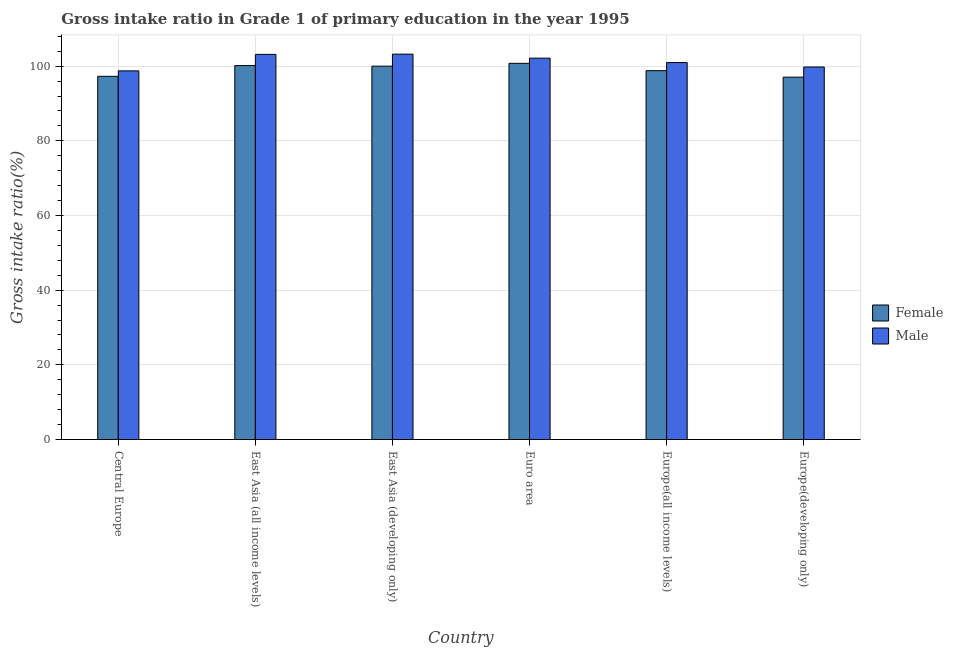How many different coloured bars are there?
Keep it short and to the point. 2. How many bars are there on the 5th tick from the left?
Make the answer very short. 2. What is the label of the 1st group of bars from the left?
Your answer should be compact. Central Europe. What is the gross intake ratio(female) in Euro area?
Ensure brevity in your answer.  100.76. Across all countries, what is the maximum gross intake ratio(male)?
Ensure brevity in your answer.  103.22. Across all countries, what is the minimum gross intake ratio(female)?
Ensure brevity in your answer.  97.06. In which country was the gross intake ratio(female) maximum?
Your answer should be very brief. Euro area. In which country was the gross intake ratio(male) minimum?
Offer a very short reply. Central Europe. What is the total gross intake ratio(female) in the graph?
Keep it short and to the point. 594.04. What is the difference between the gross intake ratio(female) in East Asia (all income levels) and that in Europe(all income levels)?
Provide a succinct answer. 1.36. What is the difference between the gross intake ratio(female) in Euro area and the gross intake ratio(male) in East Asia (all income levels)?
Your answer should be compact. -2.39. What is the average gross intake ratio(male) per country?
Offer a very short reply. 101.33. What is the difference between the gross intake ratio(male) and gross intake ratio(female) in Central Europe?
Your answer should be very brief. 1.46. In how many countries, is the gross intake ratio(male) greater than 92 %?
Your answer should be very brief. 6. What is the ratio of the gross intake ratio(male) in East Asia (all income levels) to that in Euro area?
Provide a succinct answer. 1.01. Is the difference between the gross intake ratio(male) in East Asia (developing only) and Europe(developing only) greater than the difference between the gross intake ratio(female) in East Asia (developing only) and Europe(developing only)?
Make the answer very short. Yes. What is the difference between the highest and the second highest gross intake ratio(male)?
Ensure brevity in your answer.  0.07. What is the difference between the highest and the lowest gross intake ratio(male)?
Make the answer very short. 4.48. What does the 2nd bar from the left in Europe(all income levels) represents?
Provide a short and direct response. Male. What does the 2nd bar from the right in Euro area represents?
Keep it short and to the point. Female. How many bars are there?
Provide a succinct answer. 12. Are all the bars in the graph horizontal?
Keep it short and to the point. No. Where does the legend appear in the graph?
Give a very brief answer. Center right. How many legend labels are there?
Provide a succinct answer. 2. How are the legend labels stacked?
Provide a succinct answer. Vertical. What is the title of the graph?
Ensure brevity in your answer.  Gross intake ratio in Grade 1 of primary education in the year 1995. Does "Manufacturing industries and construction" appear as one of the legend labels in the graph?
Give a very brief answer. No. What is the label or title of the X-axis?
Keep it short and to the point. Country. What is the label or title of the Y-axis?
Ensure brevity in your answer.  Gross intake ratio(%). What is the Gross intake ratio(%) of Female in Central Europe?
Make the answer very short. 97.28. What is the Gross intake ratio(%) in Male in Central Europe?
Your answer should be very brief. 98.74. What is the Gross intake ratio(%) of Female in East Asia (all income levels)?
Offer a terse response. 100.15. What is the Gross intake ratio(%) in Male in East Asia (all income levels)?
Give a very brief answer. 103.15. What is the Gross intake ratio(%) of Female in East Asia (developing only)?
Provide a short and direct response. 100. What is the Gross intake ratio(%) of Male in East Asia (developing only)?
Give a very brief answer. 103.22. What is the Gross intake ratio(%) in Female in Euro area?
Provide a succinct answer. 100.76. What is the Gross intake ratio(%) of Male in Euro area?
Make the answer very short. 102.14. What is the Gross intake ratio(%) in Female in Europe(all income levels)?
Give a very brief answer. 98.79. What is the Gross intake ratio(%) in Male in Europe(all income levels)?
Ensure brevity in your answer.  100.96. What is the Gross intake ratio(%) in Female in Europe(developing only)?
Offer a terse response. 97.06. What is the Gross intake ratio(%) of Male in Europe(developing only)?
Offer a very short reply. 99.78. Across all countries, what is the maximum Gross intake ratio(%) of Female?
Provide a short and direct response. 100.76. Across all countries, what is the maximum Gross intake ratio(%) in Male?
Offer a terse response. 103.22. Across all countries, what is the minimum Gross intake ratio(%) in Female?
Your answer should be very brief. 97.06. Across all countries, what is the minimum Gross intake ratio(%) of Male?
Offer a very short reply. 98.74. What is the total Gross intake ratio(%) of Female in the graph?
Offer a terse response. 594.04. What is the total Gross intake ratio(%) in Male in the graph?
Offer a very short reply. 607.99. What is the difference between the Gross intake ratio(%) in Female in Central Europe and that in East Asia (all income levels)?
Your answer should be compact. -2.87. What is the difference between the Gross intake ratio(%) of Male in Central Europe and that in East Asia (all income levels)?
Your answer should be compact. -4.41. What is the difference between the Gross intake ratio(%) in Female in Central Europe and that in East Asia (developing only)?
Ensure brevity in your answer.  -2.72. What is the difference between the Gross intake ratio(%) of Male in Central Europe and that in East Asia (developing only)?
Make the answer very short. -4.48. What is the difference between the Gross intake ratio(%) in Female in Central Europe and that in Euro area?
Your answer should be compact. -3.48. What is the difference between the Gross intake ratio(%) in Male in Central Europe and that in Euro area?
Your answer should be very brief. -3.4. What is the difference between the Gross intake ratio(%) in Female in Central Europe and that in Europe(all income levels)?
Keep it short and to the point. -1.51. What is the difference between the Gross intake ratio(%) in Male in Central Europe and that in Europe(all income levels)?
Keep it short and to the point. -2.22. What is the difference between the Gross intake ratio(%) of Female in Central Europe and that in Europe(developing only)?
Give a very brief answer. 0.22. What is the difference between the Gross intake ratio(%) in Male in Central Europe and that in Europe(developing only)?
Provide a short and direct response. -1.04. What is the difference between the Gross intake ratio(%) of Female in East Asia (all income levels) and that in East Asia (developing only)?
Your response must be concise. 0.15. What is the difference between the Gross intake ratio(%) of Male in East Asia (all income levels) and that in East Asia (developing only)?
Provide a succinct answer. -0.07. What is the difference between the Gross intake ratio(%) in Female in East Asia (all income levels) and that in Euro area?
Offer a very short reply. -0.61. What is the difference between the Gross intake ratio(%) in Male in East Asia (all income levels) and that in Euro area?
Your response must be concise. 1.01. What is the difference between the Gross intake ratio(%) of Female in East Asia (all income levels) and that in Europe(all income levels)?
Offer a terse response. 1.36. What is the difference between the Gross intake ratio(%) in Male in East Asia (all income levels) and that in Europe(all income levels)?
Provide a short and direct response. 2.19. What is the difference between the Gross intake ratio(%) of Female in East Asia (all income levels) and that in Europe(developing only)?
Provide a short and direct response. 3.1. What is the difference between the Gross intake ratio(%) in Male in East Asia (all income levels) and that in Europe(developing only)?
Give a very brief answer. 3.37. What is the difference between the Gross intake ratio(%) of Female in East Asia (developing only) and that in Euro area?
Your response must be concise. -0.76. What is the difference between the Gross intake ratio(%) in Male in East Asia (developing only) and that in Euro area?
Keep it short and to the point. 1.08. What is the difference between the Gross intake ratio(%) of Female in East Asia (developing only) and that in Europe(all income levels)?
Your answer should be very brief. 1.21. What is the difference between the Gross intake ratio(%) of Male in East Asia (developing only) and that in Europe(all income levels)?
Provide a short and direct response. 2.26. What is the difference between the Gross intake ratio(%) in Female in East Asia (developing only) and that in Europe(developing only)?
Give a very brief answer. 2.94. What is the difference between the Gross intake ratio(%) of Male in East Asia (developing only) and that in Europe(developing only)?
Provide a succinct answer. 3.44. What is the difference between the Gross intake ratio(%) in Female in Euro area and that in Europe(all income levels)?
Your response must be concise. 1.97. What is the difference between the Gross intake ratio(%) in Male in Euro area and that in Europe(all income levels)?
Ensure brevity in your answer.  1.18. What is the difference between the Gross intake ratio(%) in Female in Euro area and that in Europe(developing only)?
Make the answer very short. 3.7. What is the difference between the Gross intake ratio(%) of Male in Euro area and that in Europe(developing only)?
Give a very brief answer. 2.36. What is the difference between the Gross intake ratio(%) of Female in Europe(all income levels) and that in Europe(developing only)?
Give a very brief answer. 1.73. What is the difference between the Gross intake ratio(%) in Male in Europe(all income levels) and that in Europe(developing only)?
Ensure brevity in your answer.  1.18. What is the difference between the Gross intake ratio(%) in Female in Central Europe and the Gross intake ratio(%) in Male in East Asia (all income levels)?
Your response must be concise. -5.87. What is the difference between the Gross intake ratio(%) in Female in Central Europe and the Gross intake ratio(%) in Male in East Asia (developing only)?
Your answer should be very brief. -5.94. What is the difference between the Gross intake ratio(%) of Female in Central Europe and the Gross intake ratio(%) of Male in Euro area?
Keep it short and to the point. -4.86. What is the difference between the Gross intake ratio(%) in Female in Central Europe and the Gross intake ratio(%) in Male in Europe(all income levels)?
Keep it short and to the point. -3.68. What is the difference between the Gross intake ratio(%) in Female in Central Europe and the Gross intake ratio(%) in Male in Europe(developing only)?
Keep it short and to the point. -2.5. What is the difference between the Gross intake ratio(%) of Female in East Asia (all income levels) and the Gross intake ratio(%) of Male in East Asia (developing only)?
Keep it short and to the point. -3.07. What is the difference between the Gross intake ratio(%) of Female in East Asia (all income levels) and the Gross intake ratio(%) of Male in Euro area?
Offer a very short reply. -1.99. What is the difference between the Gross intake ratio(%) in Female in East Asia (all income levels) and the Gross intake ratio(%) in Male in Europe(all income levels)?
Give a very brief answer. -0.81. What is the difference between the Gross intake ratio(%) of Female in East Asia (all income levels) and the Gross intake ratio(%) of Male in Europe(developing only)?
Keep it short and to the point. 0.38. What is the difference between the Gross intake ratio(%) in Female in East Asia (developing only) and the Gross intake ratio(%) in Male in Euro area?
Keep it short and to the point. -2.14. What is the difference between the Gross intake ratio(%) in Female in East Asia (developing only) and the Gross intake ratio(%) in Male in Europe(all income levels)?
Offer a terse response. -0.96. What is the difference between the Gross intake ratio(%) in Female in East Asia (developing only) and the Gross intake ratio(%) in Male in Europe(developing only)?
Offer a terse response. 0.22. What is the difference between the Gross intake ratio(%) of Female in Euro area and the Gross intake ratio(%) of Male in Europe(all income levels)?
Your response must be concise. -0.2. What is the difference between the Gross intake ratio(%) in Female in Euro area and the Gross intake ratio(%) in Male in Europe(developing only)?
Give a very brief answer. 0.98. What is the difference between the Gross intake ratio(%) of Female in Europe(all income levels) and the Gross intake ratio(%) of Male in Europe(developing only)?
Offer a terse response. -0.99. What is the average Gross intake ratio(%) in Female per country?
Provide a short and direct response. 99.01. What is the average Gross intake ratio(%) in Male per country?
Your answer should be compact. 101.33. What is the difference between the Gross intake ratio(%) of Female and Gross intake ratio(%) of Male in Central Europe?
Keep it short and to the point. -1.46. What is the difference between the Gross intake ratio(%) of Female and Gross intake ratio(%) of Male in East Asia (all income levels)?
Your answer should be compact. -3. What is the difference between the Gross intake ratio(%) in Female and Gross intake ratio(%) in Male in East Asia (developing only)?
Your answer should be very brief. -3.22. What is the difference between the Gross intake ratio(%) of Female and Gross intake ratio(%) of Male in Euro area?
Provide a short and direct response. -1.38. What is the difference between the Gross intake ratio(%) in Female and Gross intake ratio(%) in Male in Europe(all income levels)?
Keep it short and to the point. -2.17. What is the difference between the Gross intake ratio(%) in Female and Gross intake ratio(%) in Male in Europe(developing only)?
Offer a terse response. -2.72. What is the ratio of the Gross intake ratio(%) in Female in Central Europe to that in East Asia (all income levels)?
Your answer should be compact. 0.97. What is the ratio of the Gross intake ratio(%) of Male in Central Europe to that in East Asia (all income levels)?
Provide a succinct answer. 0.96. What is the ratio of the Gross intake ratio(%) of Female in Central Europe to that in East Asia (developing only)?
Your response must be concise. 0.97. What is the ratio of the Gross intake ratio(%) of Male in Central Europe to that in East Asia (developing only)?
Offer a terse response. 0.96. What is the ratio of the Gross intake ratio(%) in Female in Central Europe to that in Euro area?
Offer a very short reply. 0.97. What is the ratio of the Gross intake ratio(%) in Male in Central Europe to that in Euro area?
Keep it short and to the point. 0.97. What is the ratio of the Gross intake ratio(%) in Female in Central Europe to that in Europe(all income levels)?
Give a very brief answer. 0.98. What is the ratio of the Gross intake ratio(%) in Female in Central Europe to that in Europe(developing only)?
Keep it short and to the point. 1. What is the ratio of the Gross intake ratio(%) in Male in East Asia (all income levels) to that in Euro area?
Make the answer very short. 1.01. What is the ratio of the Gross intake ratio(%) in Female in East Asia (all income levels) to that in Europe(all income levels)?
Provide a succinct answer. 1.01. What is the ratio of the Gross intake ratio(%) of Male in East Asia (all income levels) to that in Europe(all income levels)?
Provide a short and direct response. 1.02. What is the ratio of the Gross intake ratio(%) of Female in East Asia (all income levels) to that in Europe(developing only)?
Offer a terse response. 1.03. What is the ratio of the Gross intake ratio(%) in Male in East Asia (all income levels) to that in Europe(developing only)?
Provide a succinct answer. 1.03. What is the ratio of the Gross intake ratio(%) of Male in East Asia (developing only) to that in Euro area?
Offer a very short reply. 1.01. What is the ratio of the Gross intake ratio(%) of Female in East Asia (developing only) to that in Europe(all income levels)?
Your response must be concise. 1.01. What is the ratio of the Gross intake ratio(%) in Male in East Asia (developing only) to that in Europe(all income levels)?
Offer a terse response. 1.02. What is the ratio of the Gross intake ratio(%) of Female in East Asia (developing only) to that in Europe(developing only)?
Offer a very short reply. 1.03. What is the ratio of the Gross intake ratio(%) in Male in East Asia (developing only) to that in Europe(developing only)?
Offer a very short reply. 1.03. What is the ratio of the Gross intake ratio(%) of Female in Euro area to that in Europe(all income levels)?
Make the answer very short. 1.02. What is the ratio of the Gross intake ratio(%) of Male in Euro area to that in Europe(all income levels)?
Offer a very short reply. 1.01. What is the ratio of the Gross intake ratio(%) of Female in Euro area to that in Europe(developing only)?
Your answer should be compact. 1.04. What is the ratio of the Gross intake ratio(%) of Male in Euro area to that in Europe(developing only)?
Give a very brief answer. 1.02. What is the ratio of the Gross intake ratio(%) of Female in Europe(all income levels) to that in Europe(developing only)?
Provide a succinct answer. 1.02. What is the ratio of the Gross intake ratio(%) in Male in Europe(all income levels) to that in Europe(developing only)?
Provide a short and direct response. 1.01. What is the difference between the highest and the second highest Gross intake ratio(%) in Female?
Offer a very short reply. 0.61. What is the difference between the highest and the second highest Gross intake ratio(%) in Male?
Ensure brevity in your answer.  0.07. What is the difference between the highest and the lowest Gross intake ratio(%) of Female?
Offer a very short reply. 3.7. What is the difference between the highest and the lowest Gross intake ratio(%) of Male?
Provide a succinct answer. 4.48. 